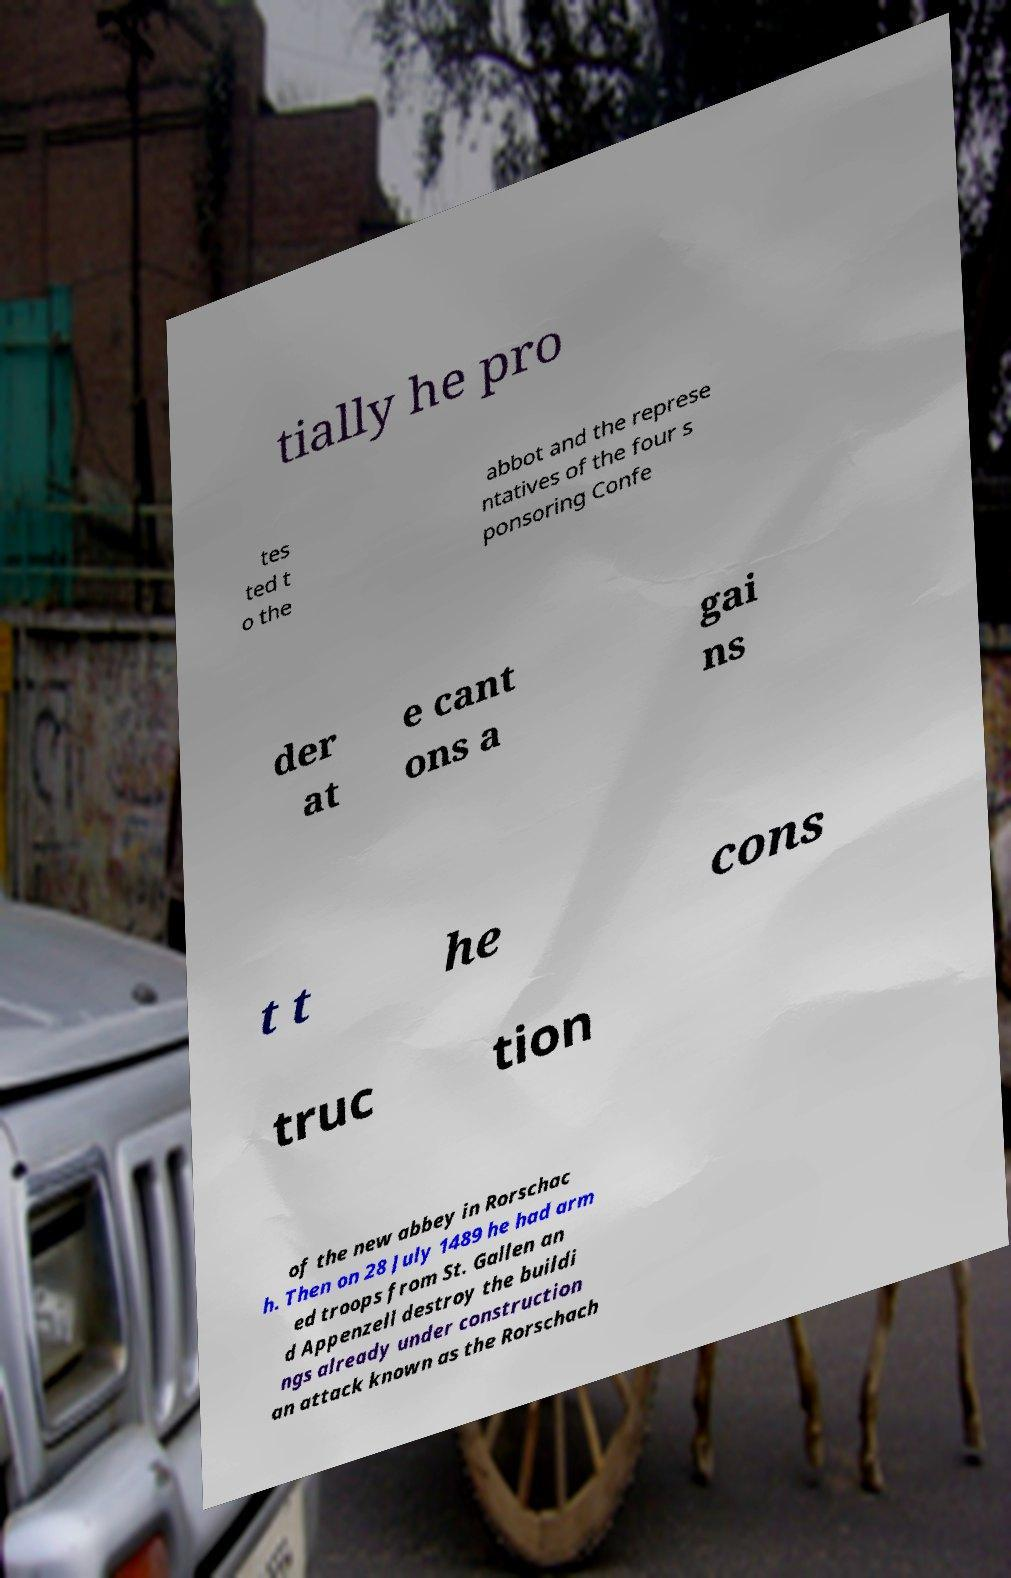What messages or text are displayed in this image? I need them in a readable, typed format. tially he pro tes ted t o the abbot and the represe ntatives of the four s ponsoring Confe der at e cant ons a gai ns t t he cons truc tion of the new abbey in Rorschac h. Then on 28 July 1489 he had arm ed troops from St. Gallen an d Appenzell destroy the buildi ngs already under construction an attack known as the Rorschach 